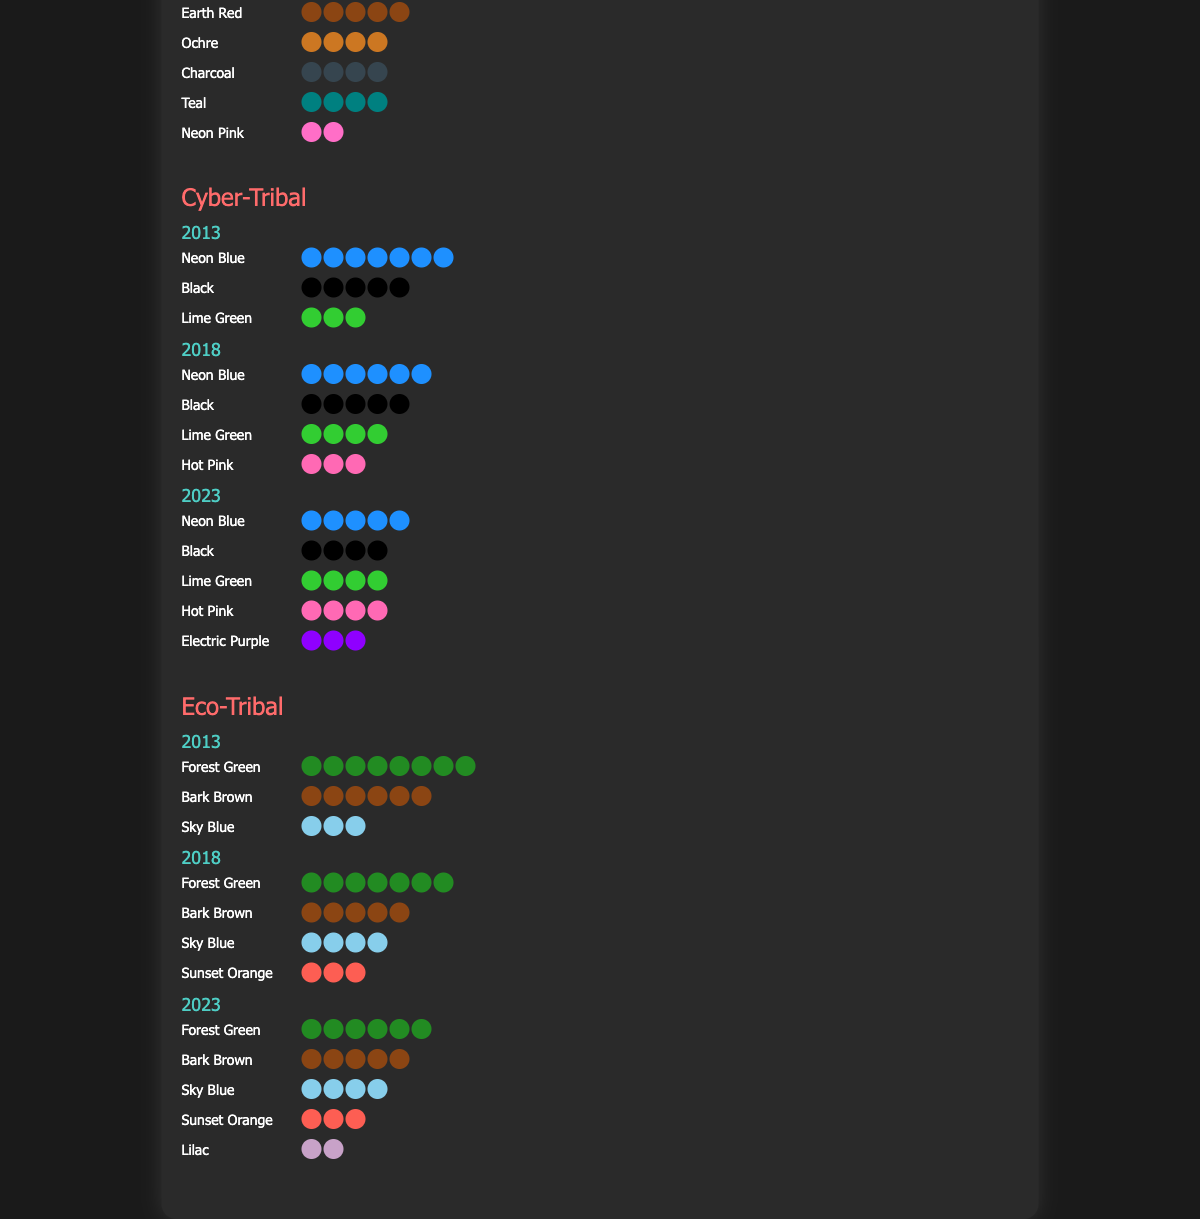What is the most common color used in the Neo-Tribal movement in 2013? We look at the color counts for the Neo-Tribal movement in 2013 and see that the "Earth Red" has the highest count of 8.
Answer: Earth Red How many new colors were introduced in the Neo-Tribal movement by 2023? By comparing the colors from 2013, 2018, and 2023 for the Neo-Tribal movement, we see "Teal" was introduced in 2018 and "Neon Pink" in 2023, totaling 2 new colors by 2023.
Answer: 2 Which year saw the introduction of the most new colors in the Cyber-Tribal movement? In the Cyber-Tribal movement, "Hot Pink" was introduced in 2018, and "Electric Purple" in 2023. Since 2018 had 1 new color and 2023 also had 1 new color, both years introduced the same number of colors.
Answer: 2018 and 2023 Has the count of "Forest Green" in the Eco-Tribal movement increased, decreased, or remained the same from 2013 to 2023? Looking at the counts for "Forest Green" in the Eco-Tribal movement, it starts at 8 in 2013, goes to 7 in 2018, and becomes 6 in 2023. This shows a decreasing trend.
Answer: Decreased How many colors are used in total across all movements in 2023? Summing the color counts for all movements in 2023: Neo-Tribal (5+4+4+4+2), Cyber-Tribal (5+4+4+4+3), and Eco-Tribal (6+5+4+3+2), we get (19+20+20) = 59.
Answer: 59 Which movement has the most vibrant color palette in 2023, considering the addition of bright colors? By analyzing colors like "Neon Pink," "Hot Pink," and "Electric Purple," we observe that the Cyber-Tribal movement includes all three (Neon Blue, Hot Pink, Electric Purple) in 2023, showing the most vibrant palette.
Answer: Cyber-Tribal Did the use of "Teal" in the Neo-Tribal movement increase, decrease, or remain the same from 2018 to 2023? In the Neo-Tribal movement, "Teal" is used 3 times in 2018 and increases to 4 times in 2023.
Answer: Increased 